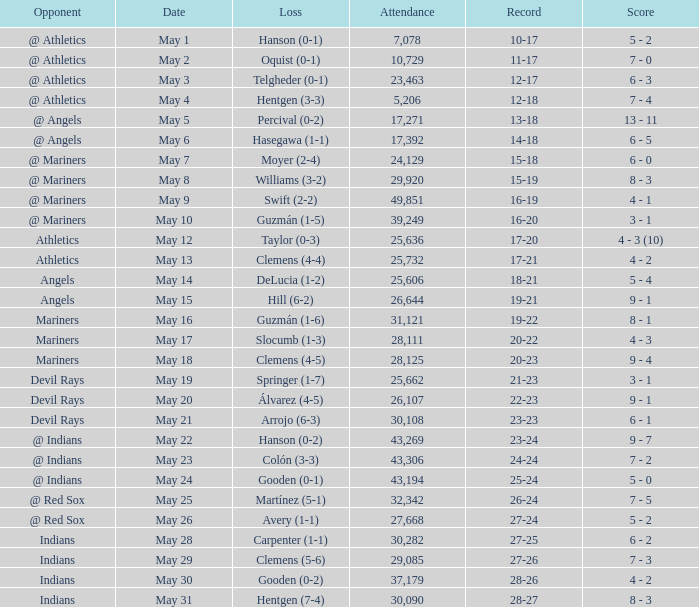When was the record 27-25? May 28. 